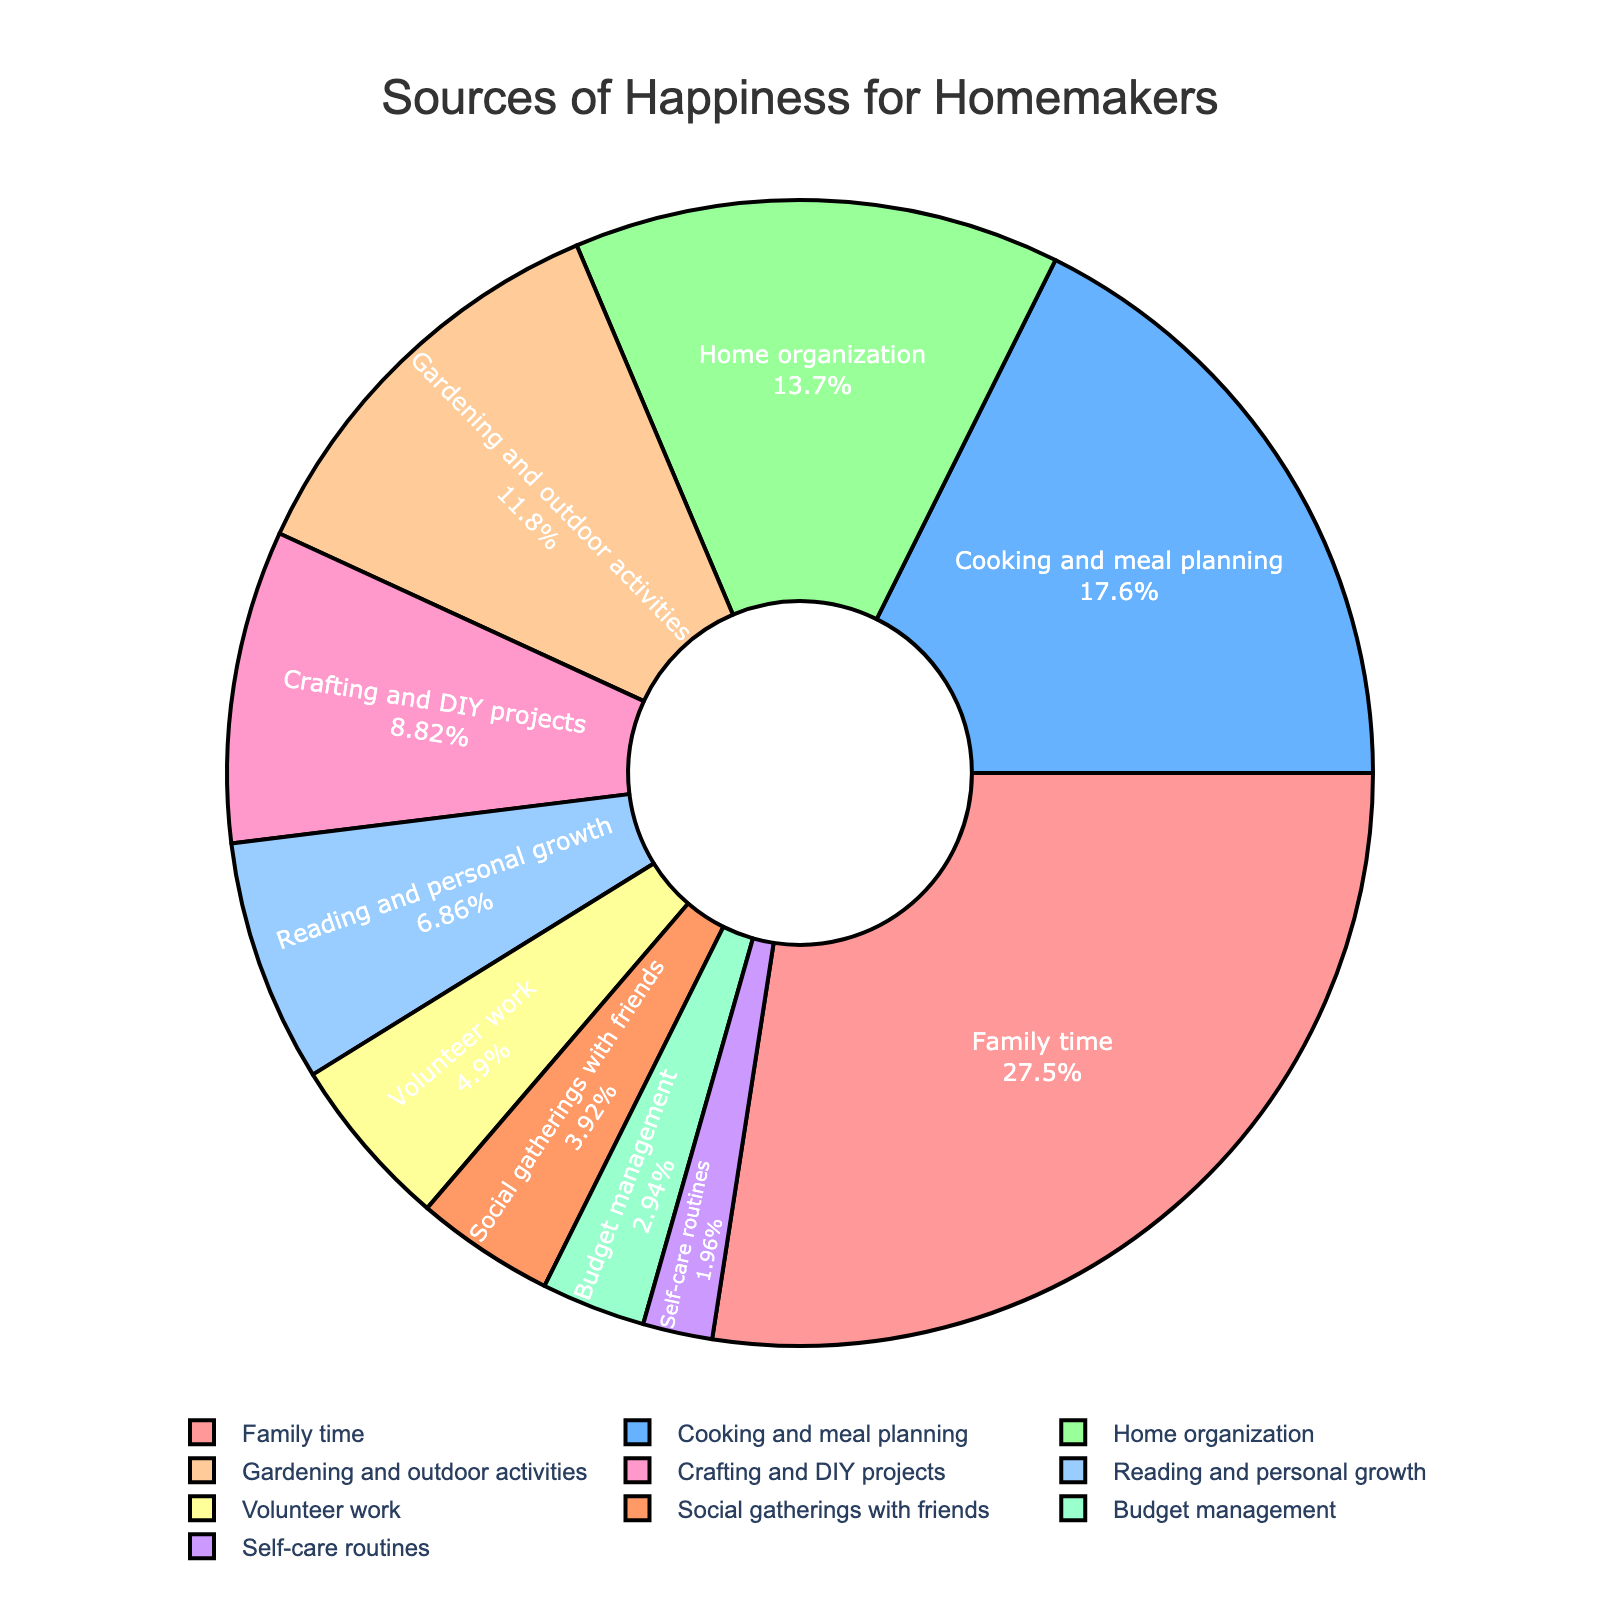Which source of happiness contributes the most for homemakers? The figure shows segments representing different sources of happiness, with "Family time" having the largest segment at 28%.
Answer: Family time What is the combined percentage of happiness derived from Cooking and meal planning and Home organization? Add the percentages of "Cooking and meal planning" (18%) and "Home organization" (14%). 18% + 14% = 32%.
Answer: 32% Which category provides less happiness: Self-care routines or Social gatherings with friends? Compare the percentages of "Self-care routines" (2%) and "Social gatherings with friends" (4%). 2% is less than 4%.
Answer: Self-care routines What percentage of happiness is provided by social activities (Volunteer work and Social gatherings with friends)? Add the percentages of "Volunteer work" (5%) and "Social gatherings with friends" (4%). 5% + 4% = 9%.
Answer: 9% Is the happiness from Gardening and outdoor activities more or less than twice the happiness from Crafting and DIY projects? Compare the percentage of "Gardening and outdoor activities" (12%) with twice the percentage of "Crafting and DIY projects" (2*9% = 18%). 12% is less than 18%.
Answer: Less What is the visual indication of the largest slice in the pie chart? The largest slice is visually the widest and is labeled "Family time" with 28%.
Answer: Family time, 28% How does the percentage of happiness from Reading and personal growth compare to that from Budget management? Compare the percentages: "Reading and personal growth" is 7%, while "Budget management" is 3%. 7% is greater than 3%.
Answer: Reading and personal growth What is the total contribution of all categories below 10% in happiness? Sum the percentages of categories below 10%: "Crafting and DIY projects" (9%), "Reading and personal growth" (7%), "Volunteer work" (5%), "Social gatherings with friends" (4%), "Budget management" (3%), and "Self-care routines" (2%). 9% + 7% + 5% + 4% + 3% + 2% = 30%.
Answer: 30% Which color represents the category with the smallest percentage and what is that percentage? Identify the color corresponding to the smallest segment, "Self-care routines," which is 2%. The color is used in the smallest segment.
Answer: Self-care routines, 2% 